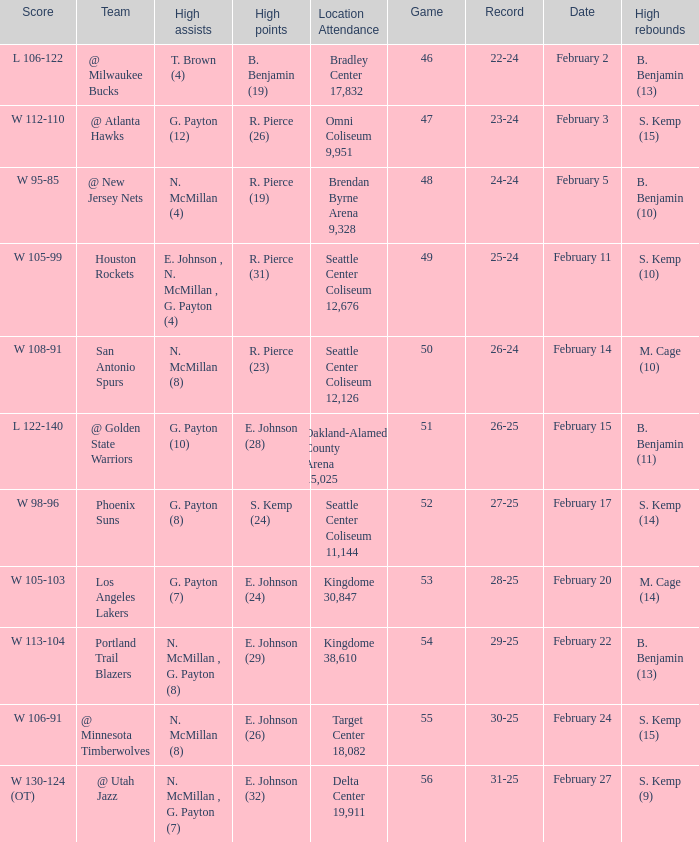Can you parse all the data within this table? {'header': ['Score', 'Team', 'High assists', 'High points', 'Location Attendance', 'Game', 'Record', 'Date', 'High rebounds'], 'rows': [['L 106-122', '@ Milwaukee Bucks', 'T. Brown (4)', 'B. Benjamin (19)', 'Bradley Center 17,832', '46', '22-24', 'February 2', 'B. Benjamin (13)'], ['W 112-110', '@ Atlanta Hawks', 'G. Payton (12)', 'R. Pierce (26)', 'Omni Coliseum 9,951', '47', '23-24', 'February 3', 'S. Kemp (15)'], ['W 95-85', '@ New Jersey Nets', 'N. McMillan (4)', 'R. Pierce (19)', 'Brendan Byrne Arena 9,328', '48', '24-24', 'February 5', 'B. Benjamin (10)'], ['W 105-99', 'Houston Rockets', 'E. Johnson , N. McMillan , G. Payton (4)', 'R. Pierce (31)', 'Seattle Center Coliseum 12,676', '49', '25-24', 'February 11', 'S. Kemp (10)'], ['W 108-91', 'San Antonio Spurs', 'N. McMillan (8)', 'R. Pierce (23)', 'Seattle Center Coliseum 12,126', '50', '26-24', 'February 14', 'M. Cage (10)'], ['L 122-140', '@ Golden State Warriors', 'G. Payton (10)', 'E. Johnson (28)', 'Oakland-Alameda County Arena 15,025', '51', '26-25', 'February 15', 'B. Benjamin (11)'], ['W 98-96', 'Phoenix Suns', 'G. Payton (8)', 'S. Kemp (24)', 'Seattle Center Coliseum 11,144', '52', '27-25', 'February 17', 'S. Kemp (14)'], ['W 105-103', 'Los Angeles Lakers', 'G. Payton (7)', 'E. Johnson (24)', 'Kingdome 30,847', '53', '28-25', 'February 20', 'M. Cage (14)'], ['W 113-104', 'Portland Trail Blazers', 'N. McMillan , G. Payton (8)', 'E. Johnson (29)', 'Kingdome 38,610', '54', '29-25', 'February 22', 'B. Benjamin (13)'], ['W 106-91', '@ Minnesota Timberwolves', 'N. McMillan (8)', 'E. Johnson (26)', 'Target Center 18,082', '55', '30-25', 'February 24', 'S. Kemp (15)'], ['W 130-124 (OT)', '@ Utah Jazz', 'N. McMillan , G. Payton (7)', 'E. Johnson (32)', 'Delta Center 19,911', '56', '31-25', 'February 27', 'S. Kemp (9)']]} What dated was the game played at the location delta center 19,911? February 27. 